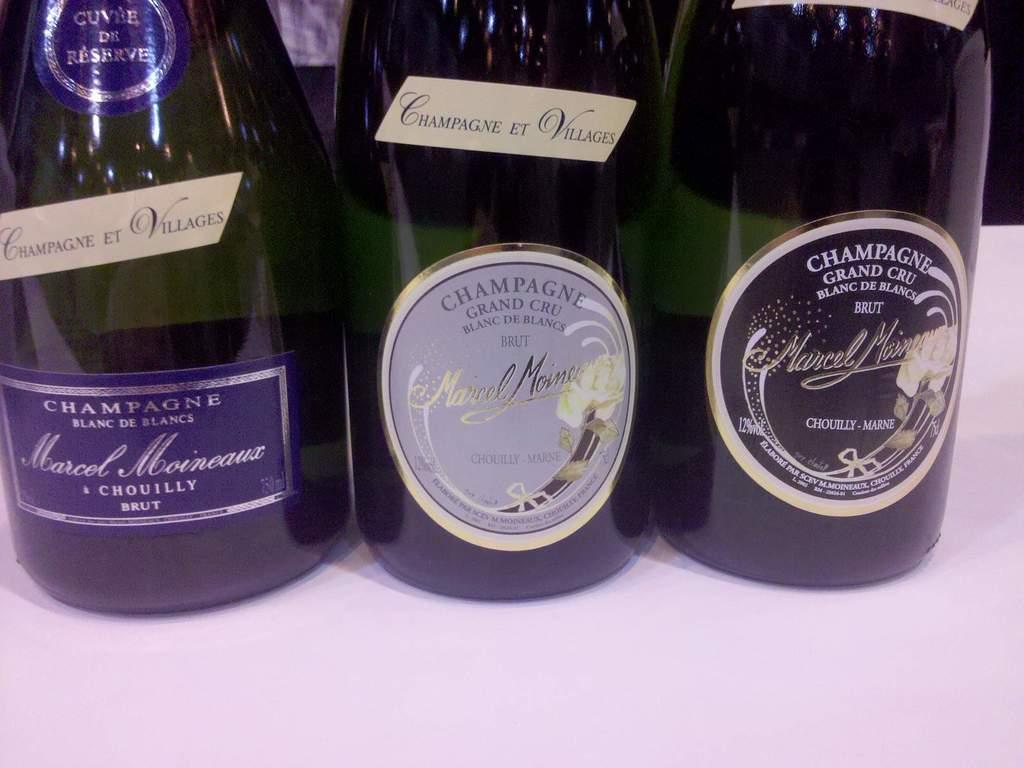Provide a one-sentence caption for the provided image. 3 bottles of wime called marcel all unopened. 